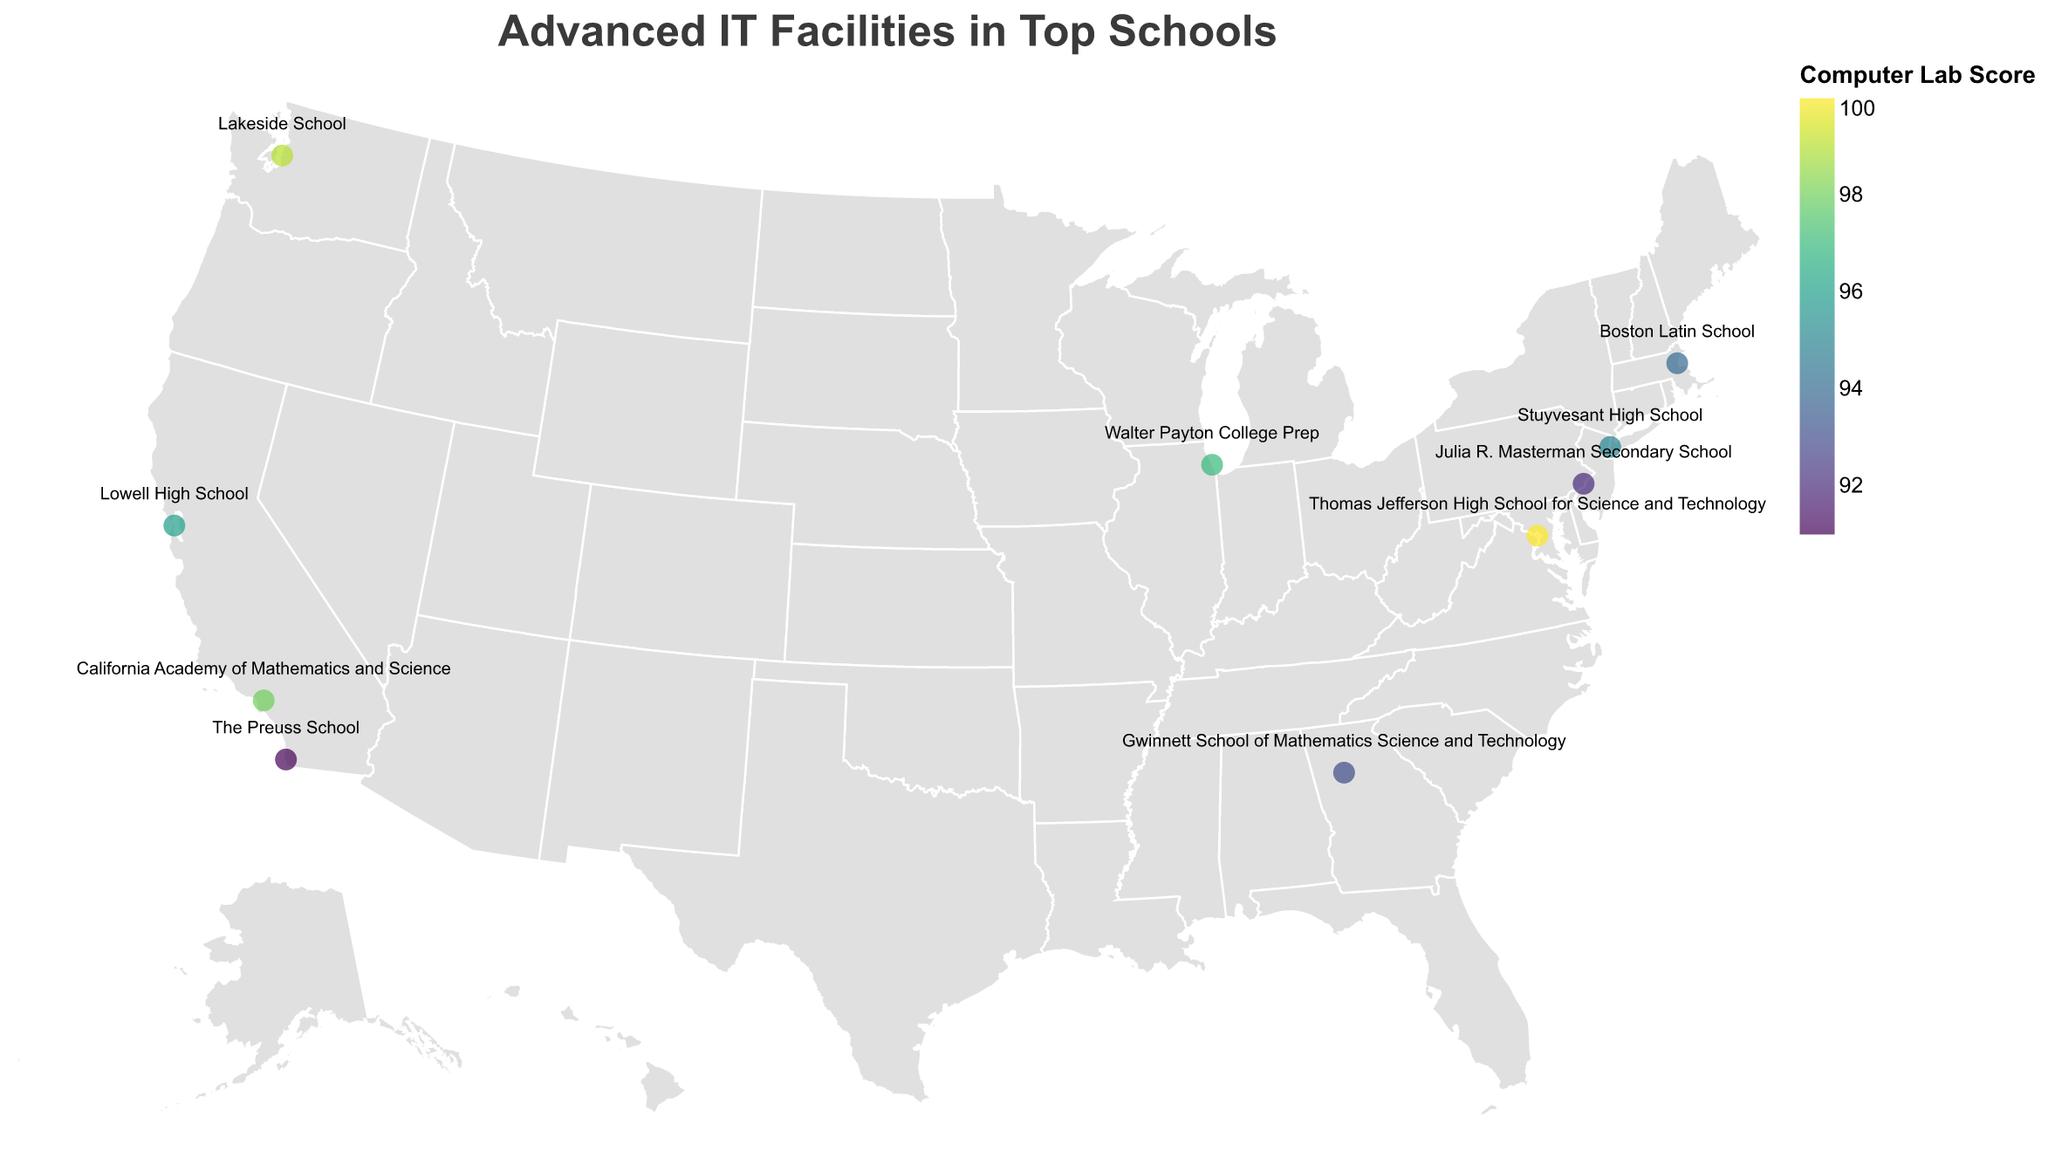How many schools are shown on the map? The map displays a heatmap with individual circles for each school. By counting the number of circles, you get the total number of schools.
Answer: 10 Which school has the highest Computer Lab Score? Look for the tooltip when hovering over each school to find the Computer Lab Score. Thomas Jefferson High School for Science and Technology has a Computer Lab Score of 100, the highest among all schools.
Answer: Thomas Jefferson High School for Science and Technology Compare the Computer Lab Scores of the schools in Los Angeles and New York. Which one is higher? California Academy of Mathematics and Science in Los Angeles has a Computer Lab Score of 98, while Stuyvesant High School in New York has a score of 95. The score in Los Angeles is higher.
Answer: California Academy of Mathematics and Science Which school has the lowest Robotics Score? By examining each school's tooltip for the Robotics Score, The Preuss School has the lowest score with 88.
Answer: The Preuss School What is the title of the map? The title is clearly displayed at the top of the map and reads "Advanced IT Facilities in Top Schools".
Answer: Advanced IT Facilities in Top Schools Calculate the average Computer Lab Score for all the schools. Sum the Computer Lab Scores of all the schools (95 + 98 + 94 + 96 + 97 + 99 + 100 + 93 + 92 + 91) = 955 and divide by the number of schools (10). The average is 955 / 10 = 95.5.
Answer: 95.5 Which region (East or West coast) contains the majority of the top-scoring Computer Labs? Summarize the number of top-scoring schools (Computer Lab Score >= 95) on both coasts. East Coast: Stuyvesant High School (95), Boston Latin School (94), Thomas Jefferson High School for Science and Technology (100), Julia R. Masterman Secondary School (92). West Coast: California Academy of Mathematics and Science (98), Lowell High School (96), Lakeside School (99), The Preuss School (91).  The West Coast has more top-scoring schools.
Answer: West Coast How many schools have both Computer Lab Scores and Robotics Scores above 90? Check the tooltips of each school to see if both scores are above 90. Schools meeting this criteria are: Stuyvesant High School, California Academy of Mathematics and Science, Boston Latin School, Lowell High School, Walter Payton College Prep, Lakeside School, Thomas Jefferson High School for Science and Technology, and Gwinnett School of Mathematics Science and Technology.
Answer: 8 Which school is located closest to the geographic center of the United States? Based on the map's projection and the central location of points, Walter Payton College Prep in Chicago, IL, is closest to the geographic center of the United States.
Answer: Walter Payton College Prep 